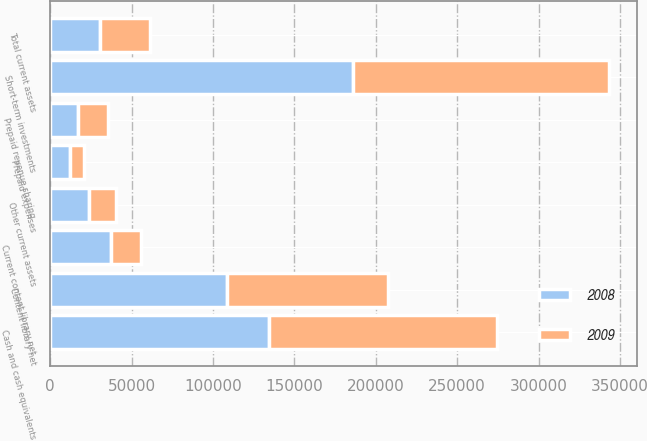<chart> <loc_0><loc_0><loc_500><loc_500><stacked_bar_chart><ecel><fcel>Cash and cash equivalents<fcel>Short-term investments<fcel>Prepaid expenses<fcel>Prepaid revenue sharing<fcel>Current content library net<fcel>Other current assets<fcel>Total current assets<fcel>Content library net<nl><fcel>2008<fcel>134224<fcel>186018<fcel>12491<fcel>17133<fcel>37329<fcel>23818<fcel>30573.5<fcel>108810<nl><fcel>2009<fcel>139881<fcel>157390<fcel>8122<fcel>18417<fcel>18691<fcel>16424<fcel>30573.5<fcel>98547<nl></chart> 